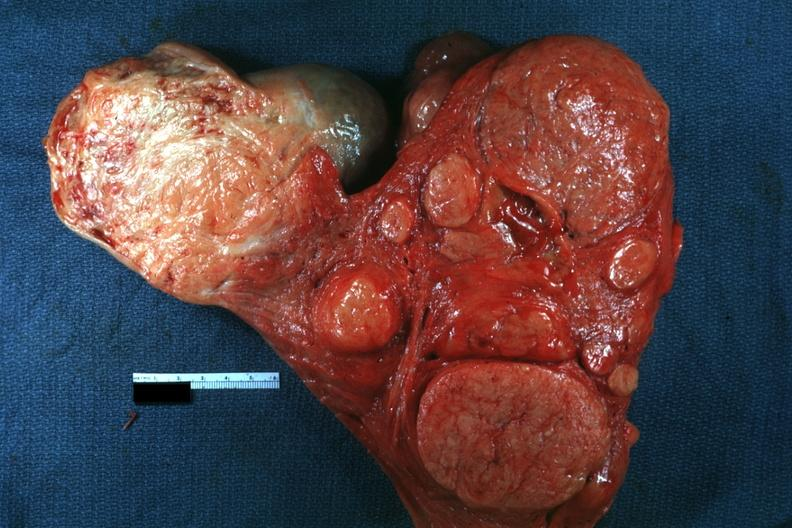s uterus present?
Answer the question using a single word or phrase. Yes 